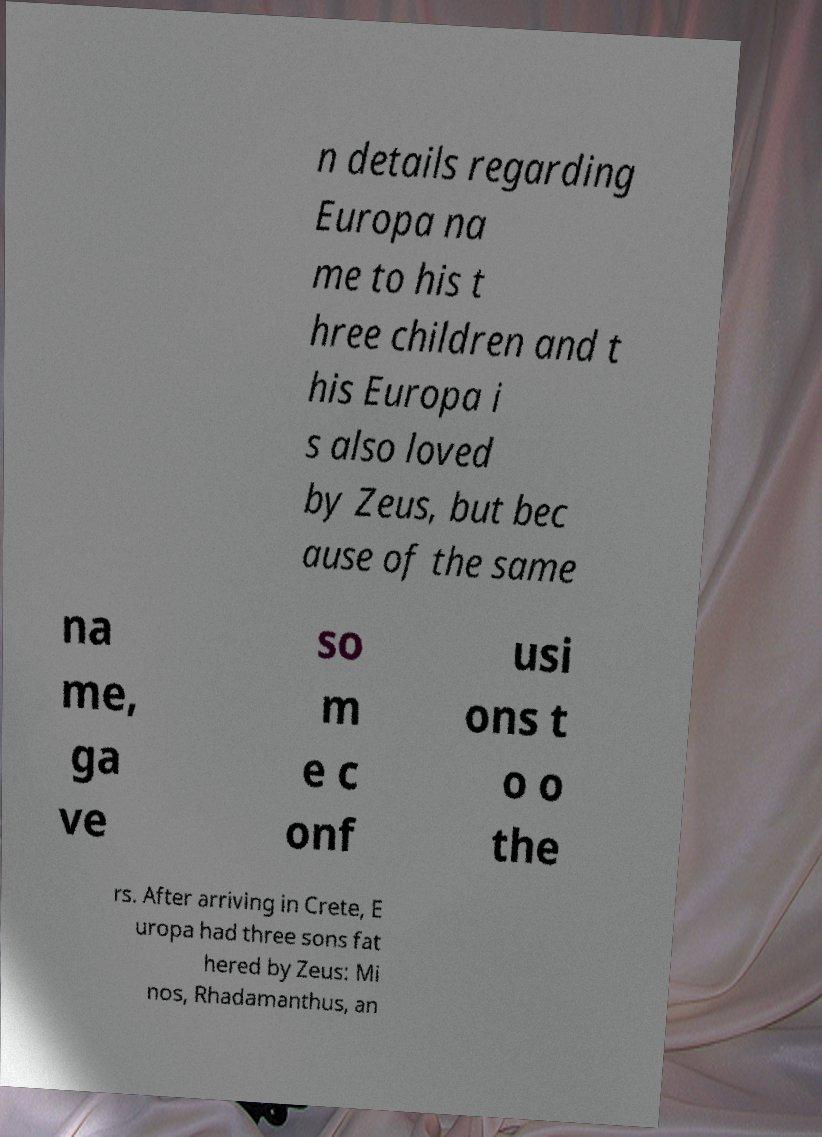Can you read and provide the text displayed in the image?This photo seems to have some interesting text. Can you extract and type it out for me? n details regarding Europa na me to his t hree children and t his Europa i s also loved by Zeus, but bec ause of the same na me, ga ve so m e c onf usi ons t o o the rs. After arriving in Crete, E uropa had three sons fat hered by Zeus: Mi nos, Rhadamanthus, an 